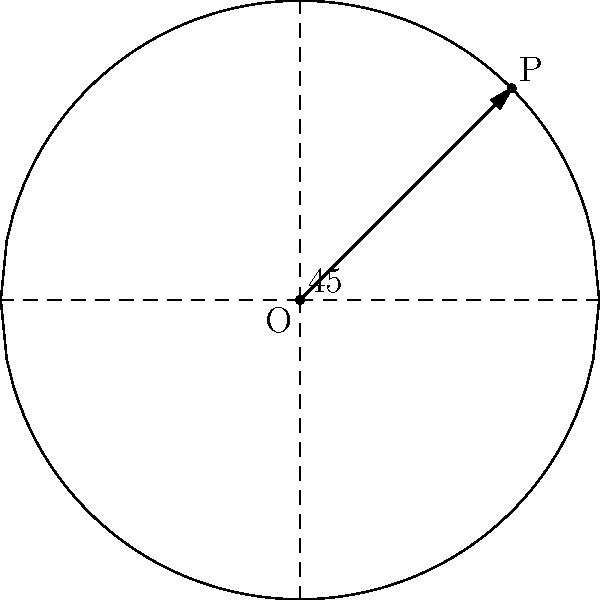In our last game, we executed a play that involved rotating our formation 45° clockwise around the center. This reminded me of a geometry problem. Consider a unit circle centered at the origin O(0,0) with point P at (cos(π/4), sin(π/4)). If we rotate the entire circle 45° clockwise around O, what will be the new coordinates of point P? Let's approach this step-by-step:

1) The initial coordinates of P are (cos(π/4), sin(π/4)).

2) To rotate a point (x, y) by an angle θ clockwise around the origin, we use the rotation matrix:
   $$ \begin{pmatrix} \cos\theta & \sin\theta \\ -\sin\theta & \cos\theta \end{pmatrix} $$

3) In this case, θ = 45° = π/4 radians.

4) We need to calculate:
   $$ \begin{pmatrix} \cos(π/4) & \sin(π/4) \\ -\sin(π/4) & \cos(π/4) \end{pmatrix} \begin{pmatrix} \cos(π/4) \\ \sin(π/4) \end{pmatrix} $$

5) Let's calculate each component:
   x' = cos(π/4) * cos(π/4) + sin(π/4) * sin(π/4)
      = cos²(π/4) + sin²(π/4)
      = 1 (using the identity cos²θ + sin²θ = 1)

   y' = -sin(π/4) * cos(π/4) + cos(π/4) * sin(π/4)
      = 0 (the terms cancel out)

6) Therefore, the new coordinates of P after rotation are (1, 0).
Answer: (1, 0) 